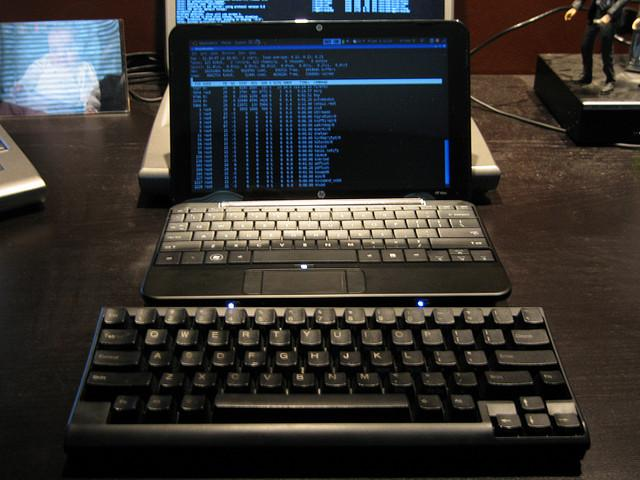Based on what's shown on the computer screen what is this person doing?

Choices:
A) writing fiction
B) shopping list
C) programming
D) gaming programming 